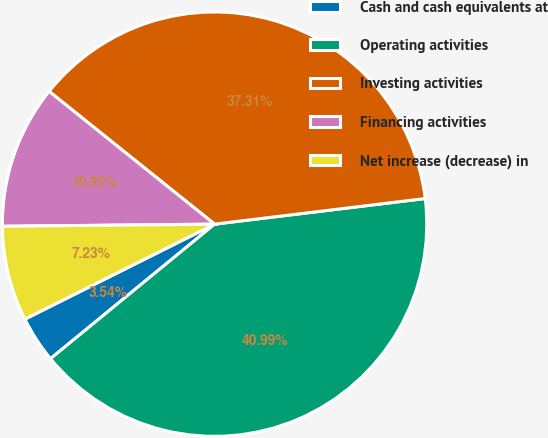Convert chart to OTSL. <chart><loc_0><loc_0><loc_500><loc_500><pie_chart><fcel>Cash and cash equivalents at<fcel>Operating activities<fcel>Investing activities<fcel>Financing activities<fcel>Net increase (decrease) in<nl><fcel>3.54%<fcel>40.99%<fcel>37.31%<fcel>10.92%<fcel>7.23%<nl></chart> 